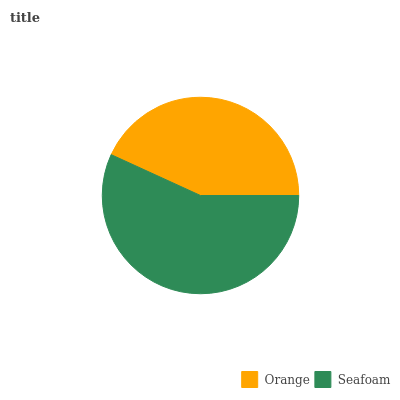Is Orange the minimum?
Answer yes or no. Yes. Is Seafoam the maximum?
Answer yes or no. Yes. Is Seafoam the minimum?
Answer yes or no. No. Is Seafoam greater than Orange?
Answer yes or no. Yes. Is Orange less than Seafoam?
Answer yes or no. Yes. Is Orange greater than Seafoam?
Answer yes or no. No. Is Seafoam less than Orange?
Answer yes or no. No. Is Seafoam the high median?
Answer yes or no. Yes. Is Orange the low median?
Answer yes or no. Yes. Is Orange the high median?
Answer yes or no. No. Is Seafoam the low median?
Answer yes or no. No. 